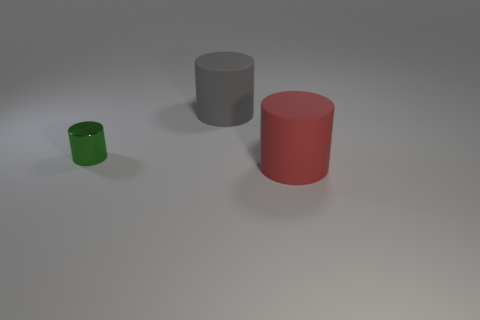Add 3 tiny yellow metallic things. How many objects exist? 6 Add 1 small cylinders. How many small cylinders are left? 2 Add 3 big yellow matte blocks. How many big yellow matte blocks exist? 3 Subtract 0 gray balls. How many objects are left? 3 Subtract all small green cylinders. Subtract all large gray matte things. How many objects are left? 1 